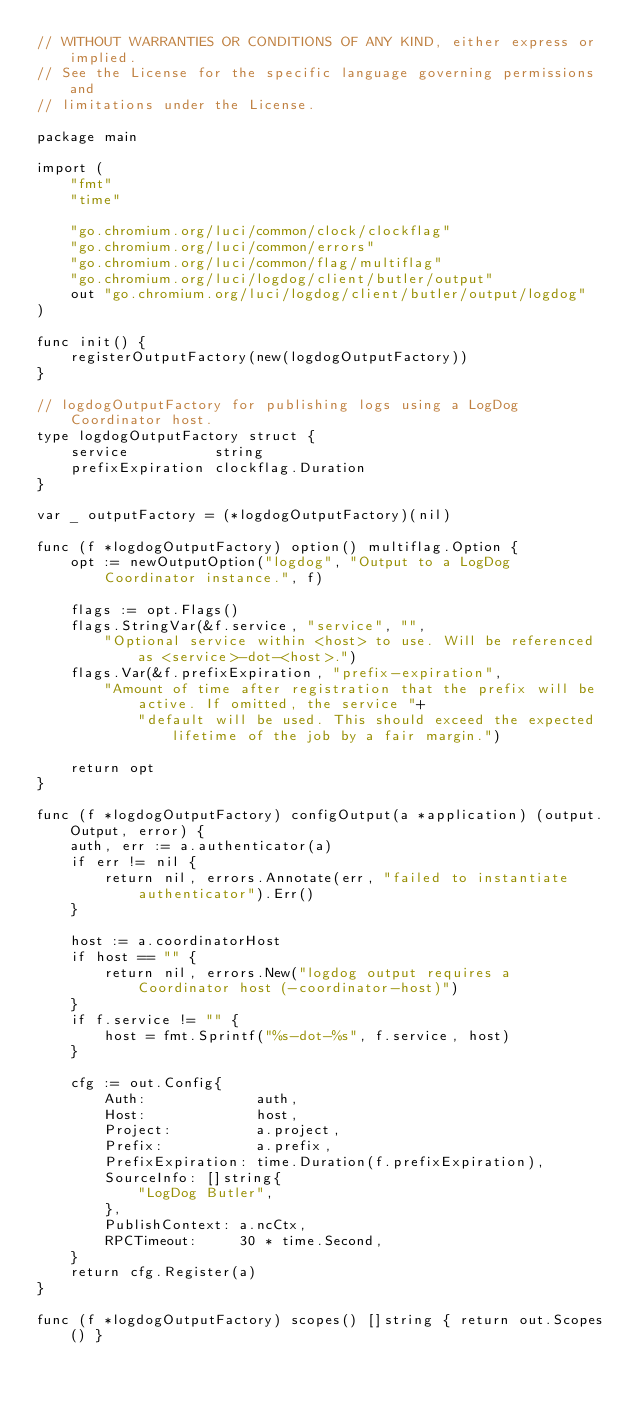<code> <loc_0><loc_0><loc_500><loc_500><_Go_>// WITHOUT WARRANTIES OR CONDITIONS OF ANY KIND, either express or implied.
// See the License for the specific language governing permissions and
// limitations under the License.

package main

import (
	"fmt"
	"time"

	"go.chromium.org/luci/common/clock/clockflag"
	"go.chromium.org/luci/common/errors"
	"go.chromium.org/luci/common/flag/multiflag"
	"go.chromium.org/luci/logdog/client/butler/output"
	out "go.chromium.org/luci/logdog/client/butler/output/logdog"
)

func init() {
	registerOutputFactory(new(logdogOutputFactory))
}

// logdogOutputFactory for publishing logs using a LogDog Coordinator host.
type logdogOutputFactory struct {
	service          string
	prefixExpiration clockflag.Duration
}

var _ outputFactory = (*logdogOutputFactory)(nil)

func (f *logdogOutputFactory) option() multiflag.Option {
	opt := newOutputOption("logdog", "Output to a LogDog Coordinator instance.", f)

	flags := opt.Flags()
	flags.StringVar(&f.service, "service", "",
		"Optional service within <host> to use. Will be referenced as <service>-dot-<host>.")
	flags.Var(&f.prefixExpiration, "prefix-expiration",
		"Amount of time after registration that the prefix will be active. If omitted, the service "+
			"default will be used. This should exceed the expected lifetime of the job by a fair margin.")

	return opt
}

func (f *logdogOutputFactory) configOutput(a *application) (output.Output, error) {
	auth, err := a.authenticator(a)
	if err != nil {
		return nil, errors.Annotate(err, "failed to instantiate authenticator").Err()
	}

	host := a.coordinatorHost
	if host == "" {
		return nil, errors.New("logdog output requires a Coordinator host (-coordinator-host)")
	}
	if f.service != "" {
		host = fmt.Sprintf("%s-dot-%s", f.service, host)
	}

	cfg := out.Config{
		Auth:             auth,
		Host:             host,
		Project:          a.project,
		Prefix:           a.prefix,
		PrefixExpiration: time.Duration(f.prefixExpiration),
		SourceInfo: []string{
			"LogDog Butler",
		},
		PublishContext: a.ncCtx,
		RPCTimeout:     30 * time.Second,
	}
	return cfg.Register(a)
}

func (f *logdogOutputFactory) scopes() []string { return out.Scopes() }
</code> 